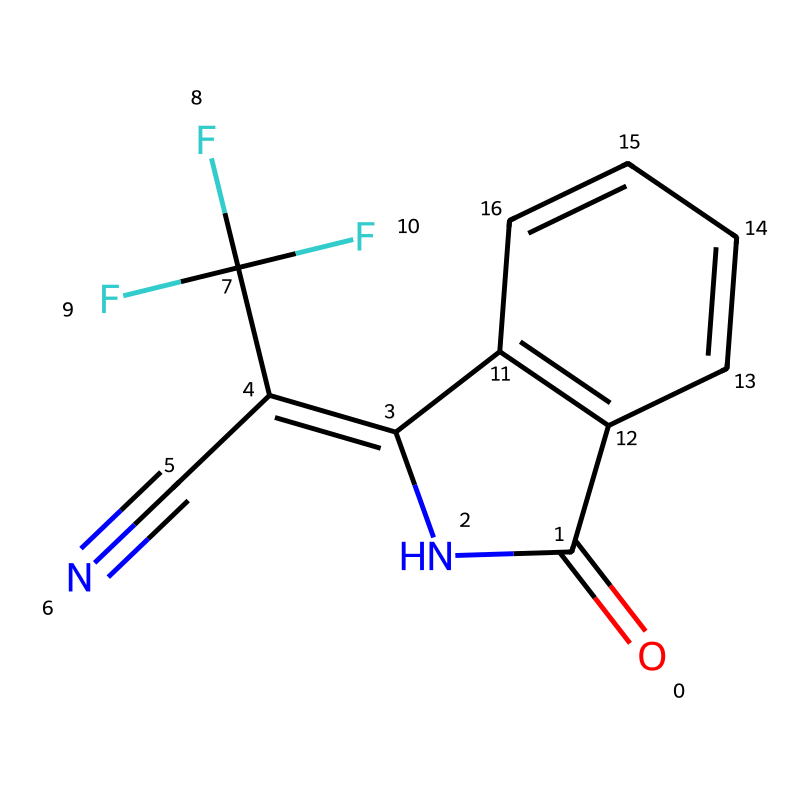What is the chemical name of this compound? The SMILES representation is specific to fludioxonil. SMILES encodes the structure in a way that allows the identification of the compound, which matches the known name of fludioxonil.
Answer: fludioxonil How many carbon atoms are in the structure? By analyzing the SMILES representation, we can count the carbon (C) symbols present. The structure contains a total of 9 carbon atoms categorized by their positions in the rings and side groups.
Answer: 9 What functional group is indicated by the "N" in the structure? The "N" in the structure indicates a nitrogen atom, which is part of an amine group. This is usually involved in biological activities and is crucial for the fungicidal properties of fludioxonil.
Answer: amine How many rings are present in the molecular structure? To determine the number of rings, we can observe the ring structures in the SMILES notation. The presence of the numbers indicates the connections made to form two distinct rings in the compound.
Answer: 2 What type of chemical classification does fludioxonil belong to? Fludioxonil is classified as a fungicide, which specifically targets fungal pathogens. The structure also reveals features typical for this class of chemicals, such as the multiple functional groups involved in antifungal activity.
Answer: fungicide Does this molecule contain any halogens? The presence of "F" in the structure indicates that there are fluorine atoms attached. The presence of these halogens contributes to the biological activity and effectiveness of the fungicide.
Answer: yes What is the significance of the cyano (C#N) group in this compound? The cyano (C#N) group is crucial as it enhances the fungicidal activity of fludioxonil. This group participates significantly in the chemical's biological mechanism against fungi, marking it as an important feature in its structure.
Answer: enhances activity 